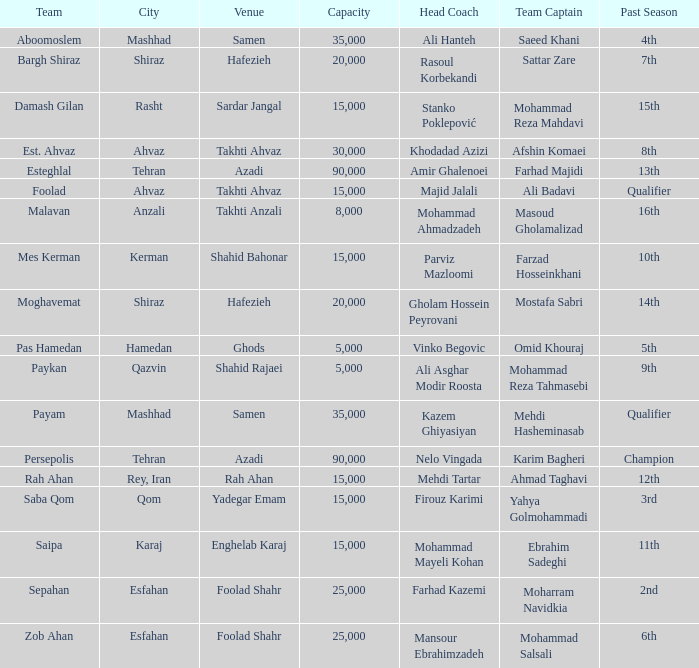What is the seating capacity at the location of head coach farhad kazemi's events? 25000.0. 